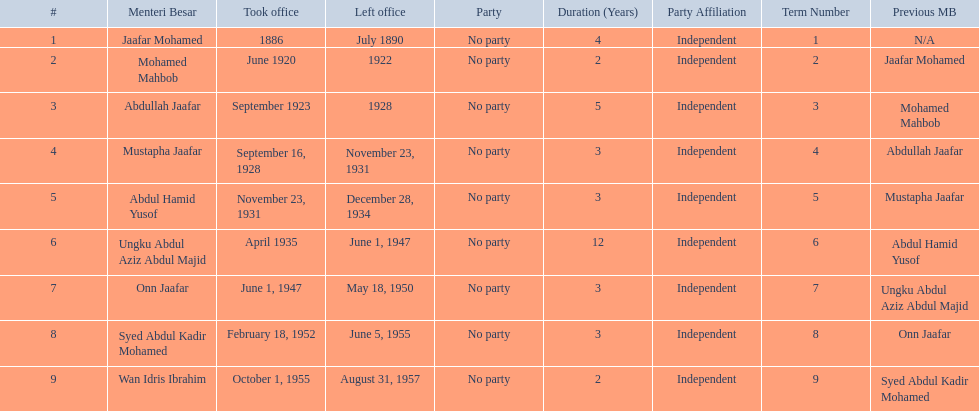Who is listed below onn jaafar? Syed Abdul Kadir Mohamed. 